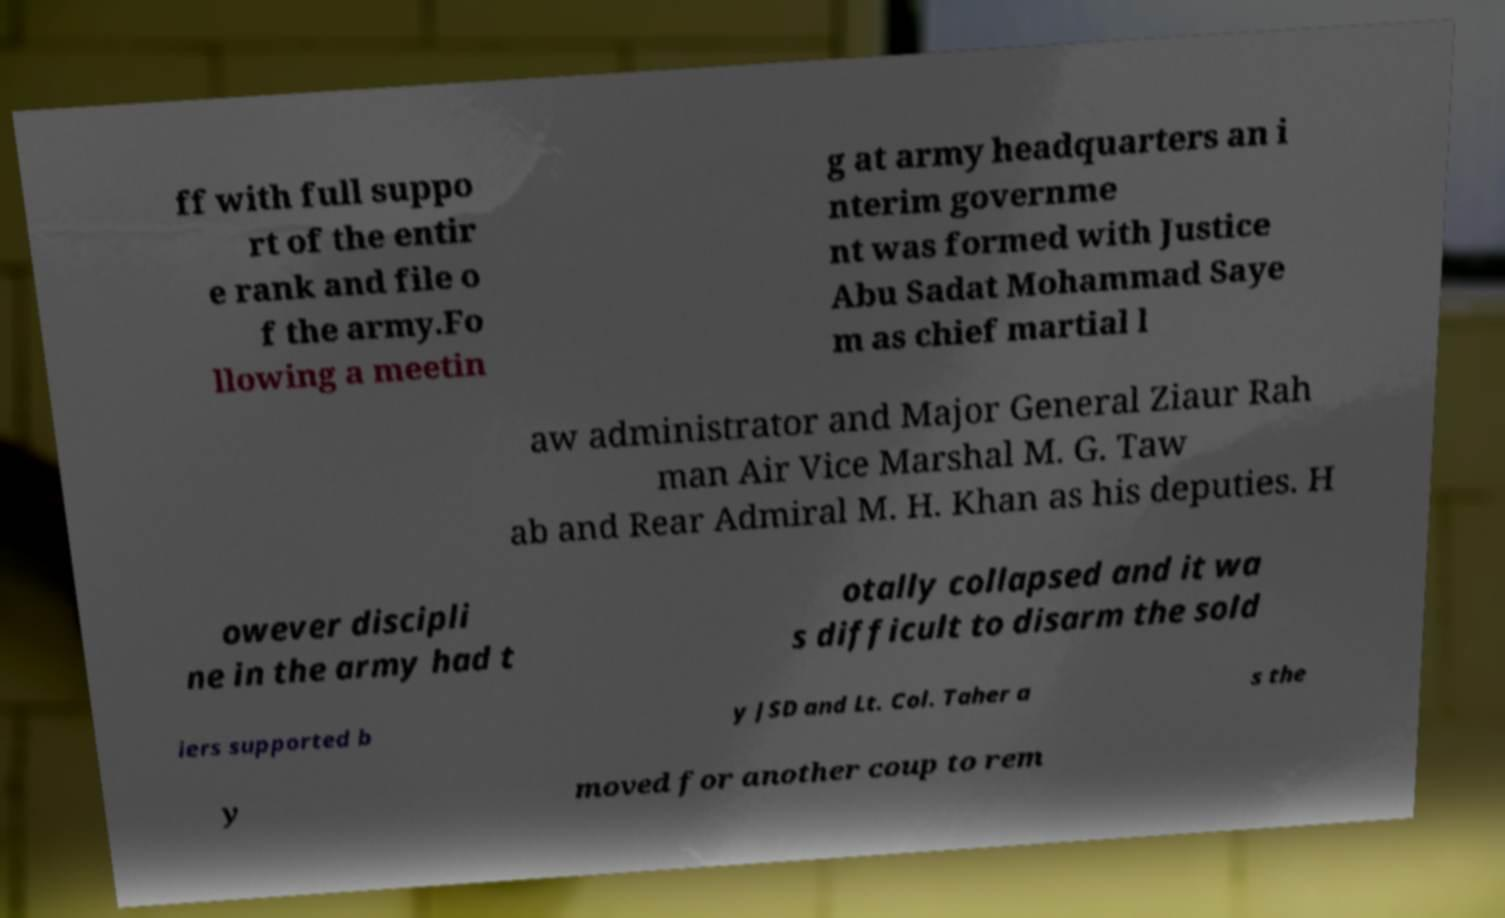Please identify and transcribe the text found in this image. ff with full suppo rt of the entir e rank and file o f the army.Fo llowing a meetin g at army headquarters an i nterim governme nt was formed with Justice Abu Sadat Mohammad Saye m as chief martial l aw administrator and Major General Ziaur Rah man Air Vice Marshal M. G. Taw ab and Rear Admiral M. H. Khan as his deputies. H owever discipli ne in the army had t otally collapsed and it wa s difficult to disarm the sold iers supported b y JSD and Lt. Col. Taher a s the y moved for another coup to rem 